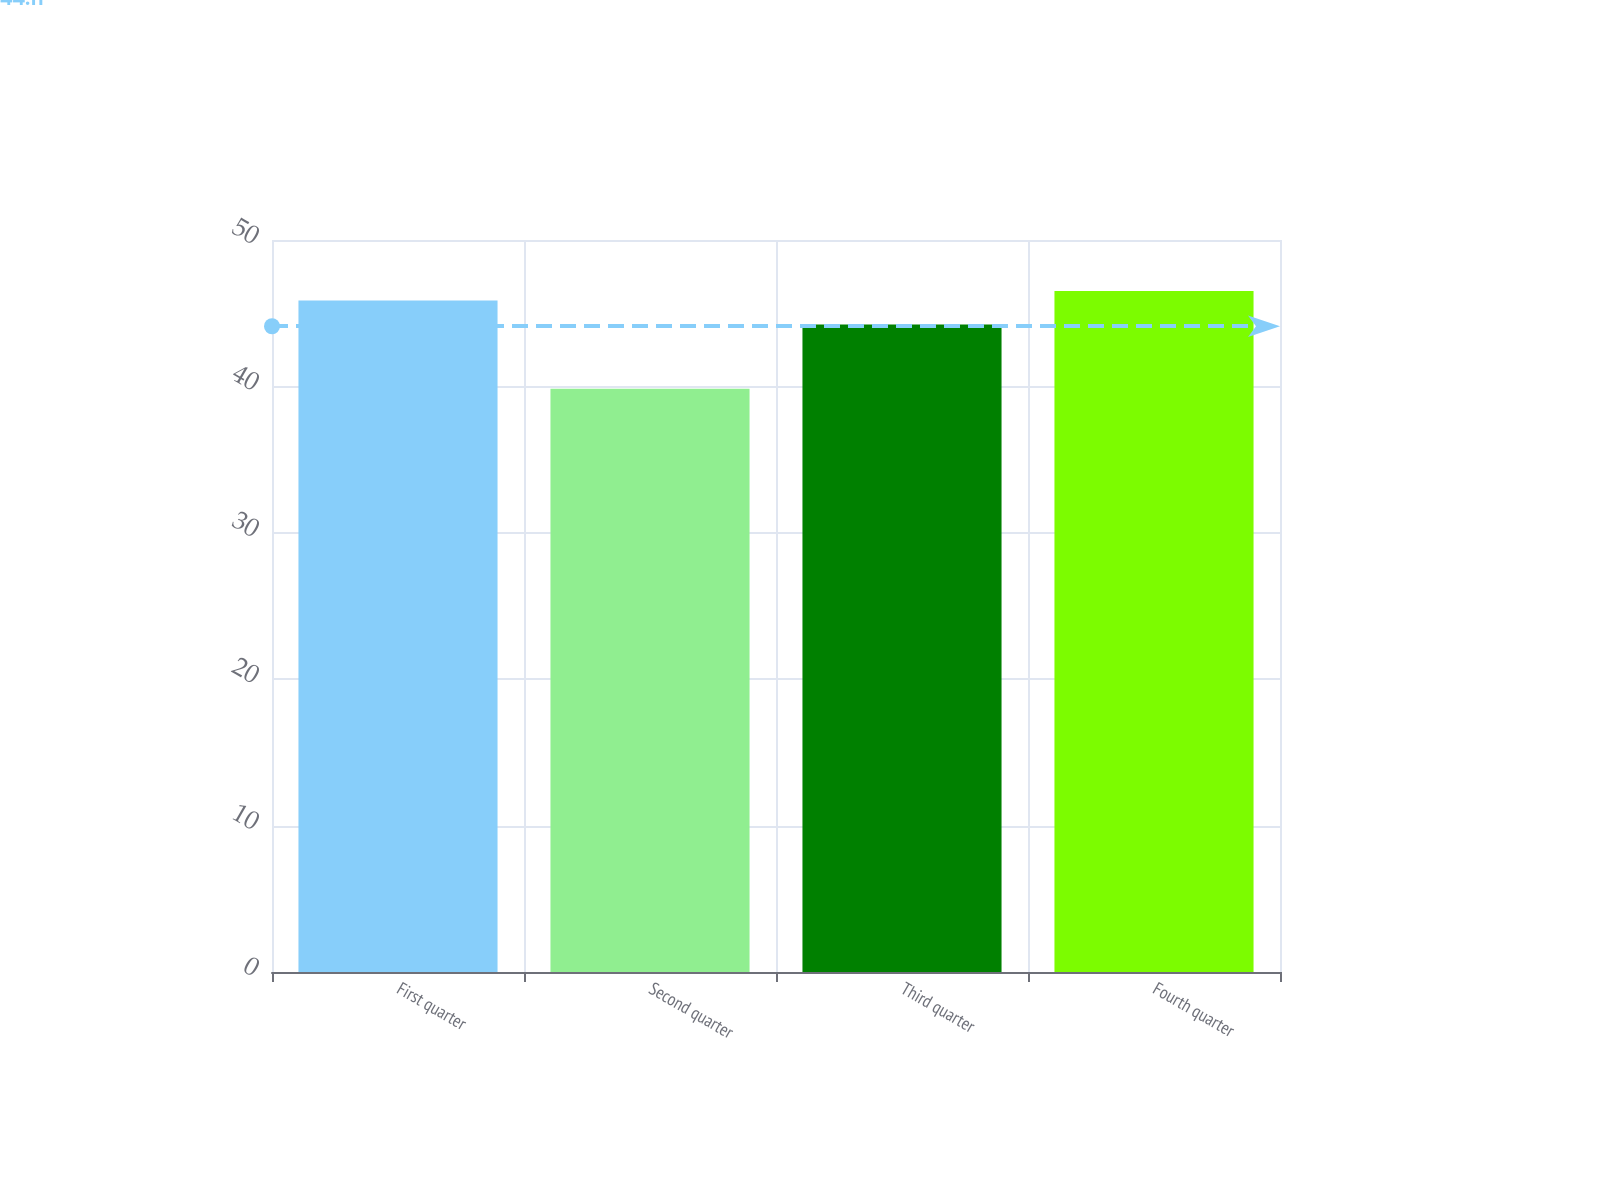Convert chart. <chart><loc_0><loc_0><loc_500><loc_500><bar_chart><fcel>First quarter<fcel>Second quarter<fcel>Third quarter<fcel>Fourth quarter<nl><fcel>45.86<fcel>39.84<fcel>44.22<fcel>46.51<nl></chart> 